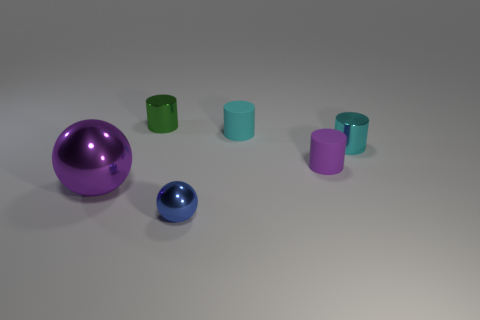What is the shape of the purple thing that is on the left side of the small blue sphere?
Offer a terse response. Sphere. There is a tiny metallic thing that is in front of the purple sphere; is it the same color as the big metal thing?
Ensure brevity in your answer.  No. Are there fewer small metallic balls that are in front of the tiny blue metallic thing than big blue matte balls?
Offer a very short reply. No. The tiny thing that is the same material as the tiny purple cylinder is what color?
Your answer should be very brief. Cyan. There is a ball left of the blue metallic object; what is its size?
Your response must be concise. Large. Are the small ball and the purple ball made of the same material?
Ensure brevity in your answer.  Yes. There is a shiny cylinder left of the small shiny object that is in front of the big shiny object; are there any small green cylinders right of it?
Offer a terse response. No. What color is the big metal ball?
Offer a terse response. Purple. There is another matte cylinder that is the same size as the cyan matte cylinder; what color is it?
Keep it short and to the point. Purple. There is a purple thing that is to the right of the purple sphere; is it the same shape as the blue shiny thing?
Provide a succinct answer. No. 